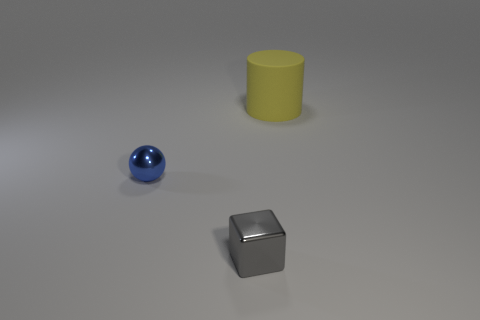Is there any other thing that has the same size as the matte thing?
Keep it short and to the point. No. What is the size of the object that is made of the same material as the small blue ball?
Your response must be concise. Small. Are there fewer blue spheres than large cyan objects?
Ensure brevity in your answer.  No. What number of tiny things are either metal objects or matte balls?
Offer a very short reply. 2. How many things are both to the right of the blue object and behind the block?
Your answer should be compact. 1. Is the number of large cyan things greater than the number of small blocks?
Keep it short and to the point. No. What number of other objects are the same shape as the yellow object?
Ensure brevity in your answer.  0. Is the small metal cube the same color as the cylinder?
Keep it short and to the point. No. There is a thing that is both right of the tiny blue sphere and in front of the big yellow rubber thing; what material is it?
Provide a succinct answer. Metal. What size is the yellow cylinder?
Make the answer very short. Large. 